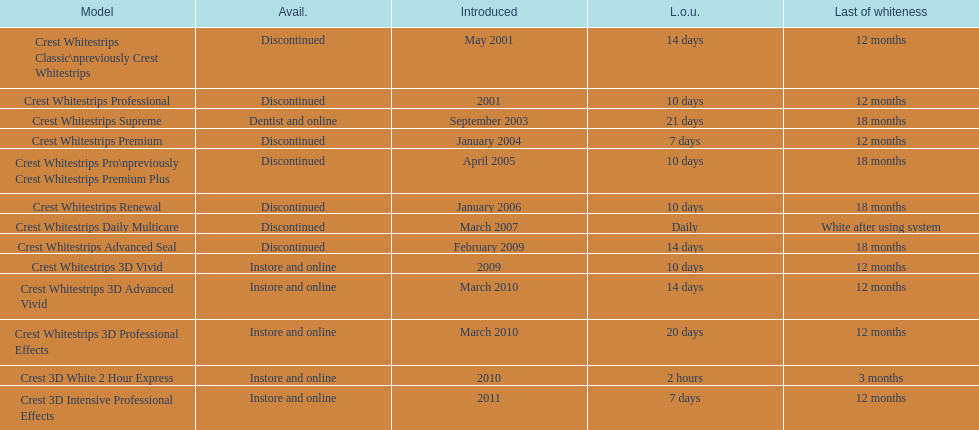Crest 3d intensive professional effects and crest whitestrips 3d professional effects both have a lasting whiteness of how many months? 12 months. 